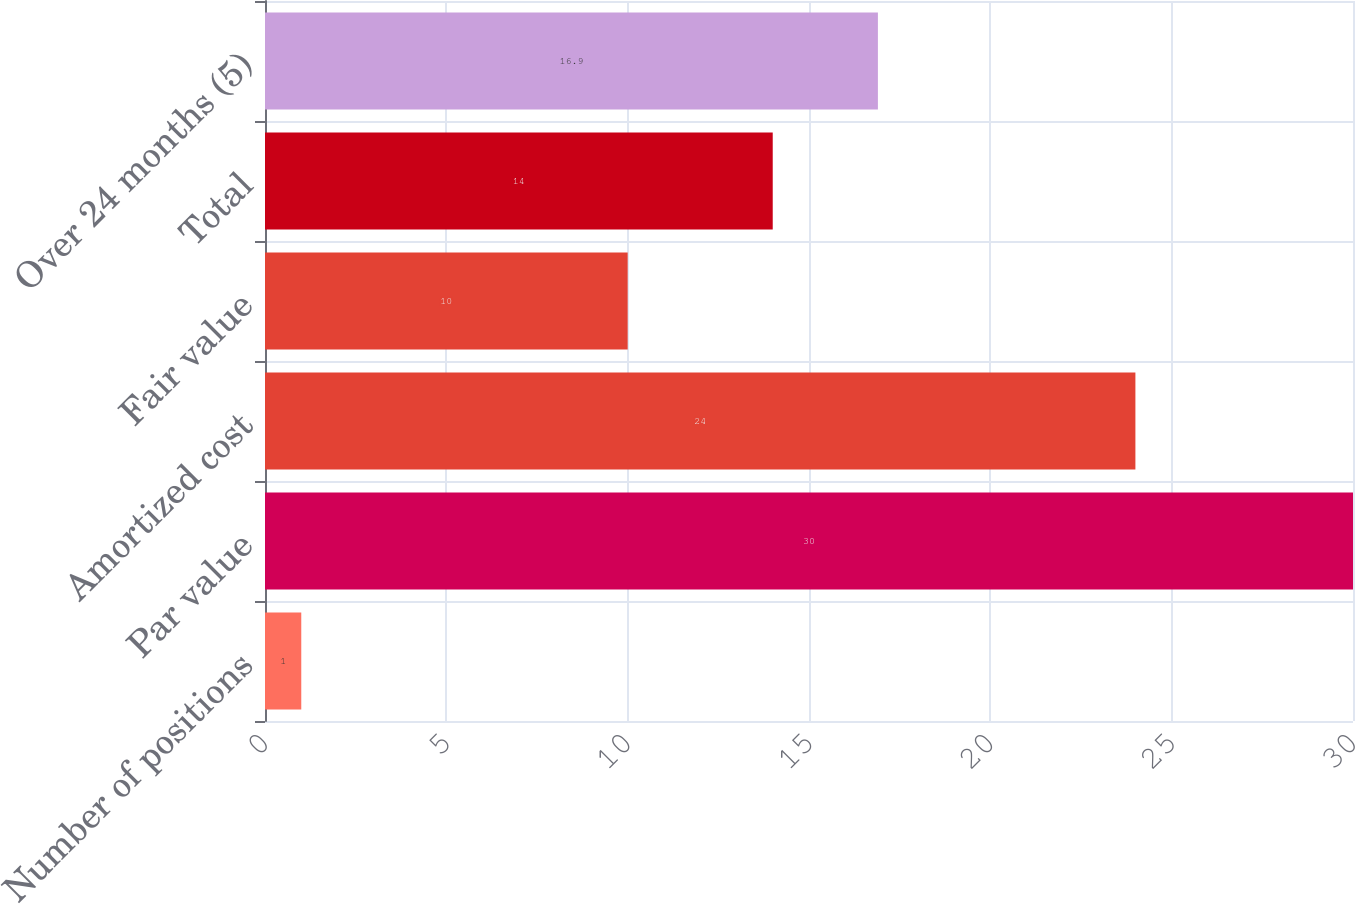<chart> <loc_0><loc_0><loc_500><loc_500><bar_chart><fcel>Number of positions<fcel>Par value<fcel>Amortized cost<fcel>Fair value<fcel>Total<fcel>Over 24 months (5)<nl><fcel>1<fcel>30<fcel>24<fcel>10<fcel>14<fcel>16.9<nl></chart> 